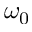<formula> <loc_0><loc_0><loc_500><loc_500>\omega _ { 0 }</formula> 